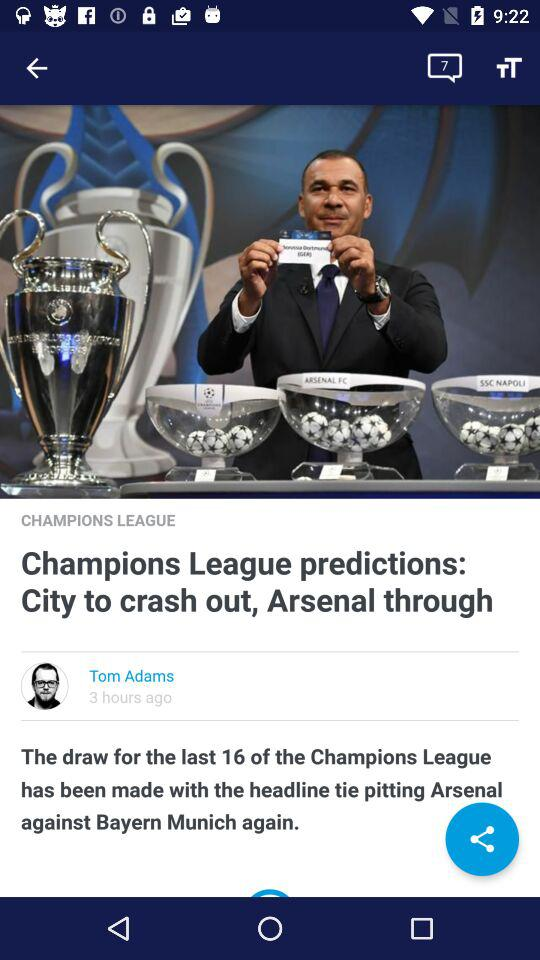What is the name of the user? The name of the user is Tom Adams. 